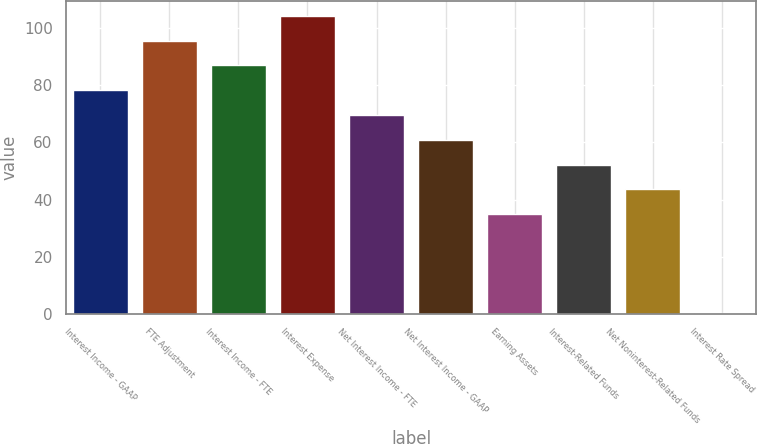<chart> <loc_0><loc_0><loc_500><loc_500><bar_chart><fcel>Interest Income - GAAP<fcel>FTE Adjustment<fcel>Interest Income - FTE<fcel>Interest Expense<fcel>Net Interest Income - FTE<fcel>Net Interest Income - GAAP<fcel>Earning Assets<fcel>Interest-Related Funds<fcel>Net Noninterest-Related Funds<fcel>Interest Rate Spread<nl><fcel>78.32<fcel>95.7<fcel>87.01<fcel>104.39<fcel>69.63<fcel>60.94<fcel>34.87<fcel>52.25<fcel>43.56<fcel>0.11<nl></chart> 